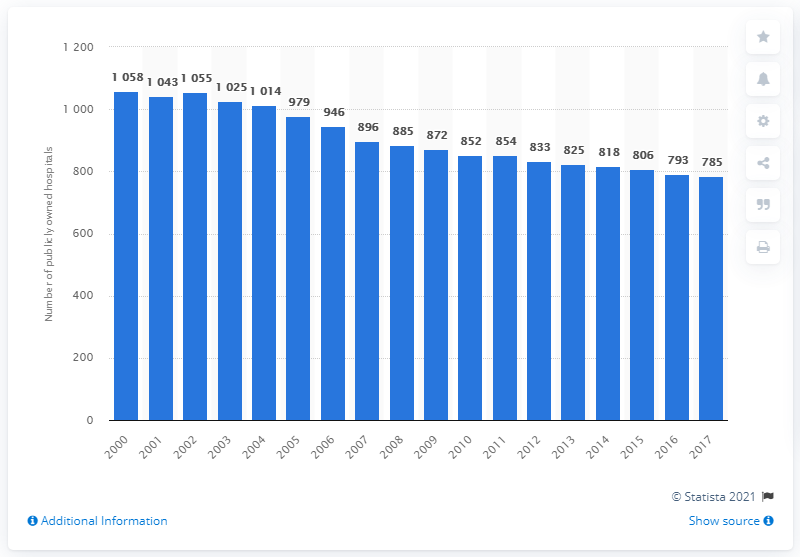Specify some key components in this picture. There were 785 publicly owned hospitals in Germany in 2017. 